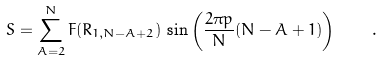Convert formula to latex. <formula><loc_0><loc_0><loc_500><loc_500>S = \sum _ { A = 2 } ^ { N } F ( R _ { 1 , N - A + 2 } ) \, \sin \left ( \frac { 2 \pi p } { N } ( N - A + 1 ) \right ) \quad .</formula> 